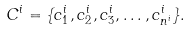Convert formula to latex. <formula><loc_0><loc_0><loc_500><loc_500>C ^ { i } = \{ c ^ { i } _ { 1 } , c ^ { i } _ { 2 } , c ^ { i } _ { 3 } , \dots , c ^ { i } _ { n ^ { i } } \} .</formula> 